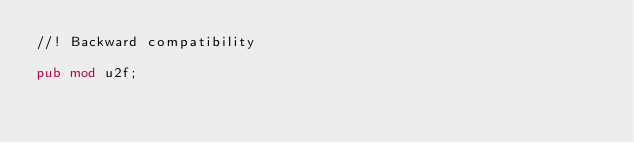Convert code to text. <code><loc_0><loc_0><loc_500><loc_500><_Rust_>//! Backward compatibility

pub mod u2f;
</code> 